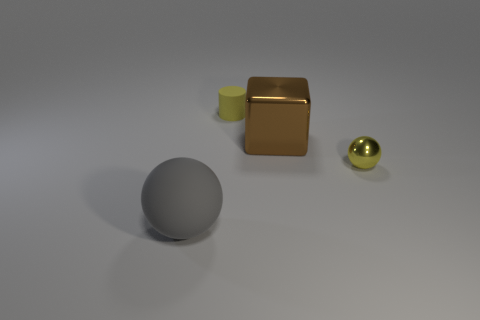Add 1 yellow objects. How many objects exist? 5 Subtract all blocks. How many objects are left? 3 Add 1 big cubes. How many big cubes exist? 2 Subtract 0 purple blocks. How many objects are left? 4 Subtract all yellow balls. Subtract all small matte cylinders. How many objects are left? 2 Add 1 tiny rubber cylinders. How many tiny rubber cylinders are left? 2 